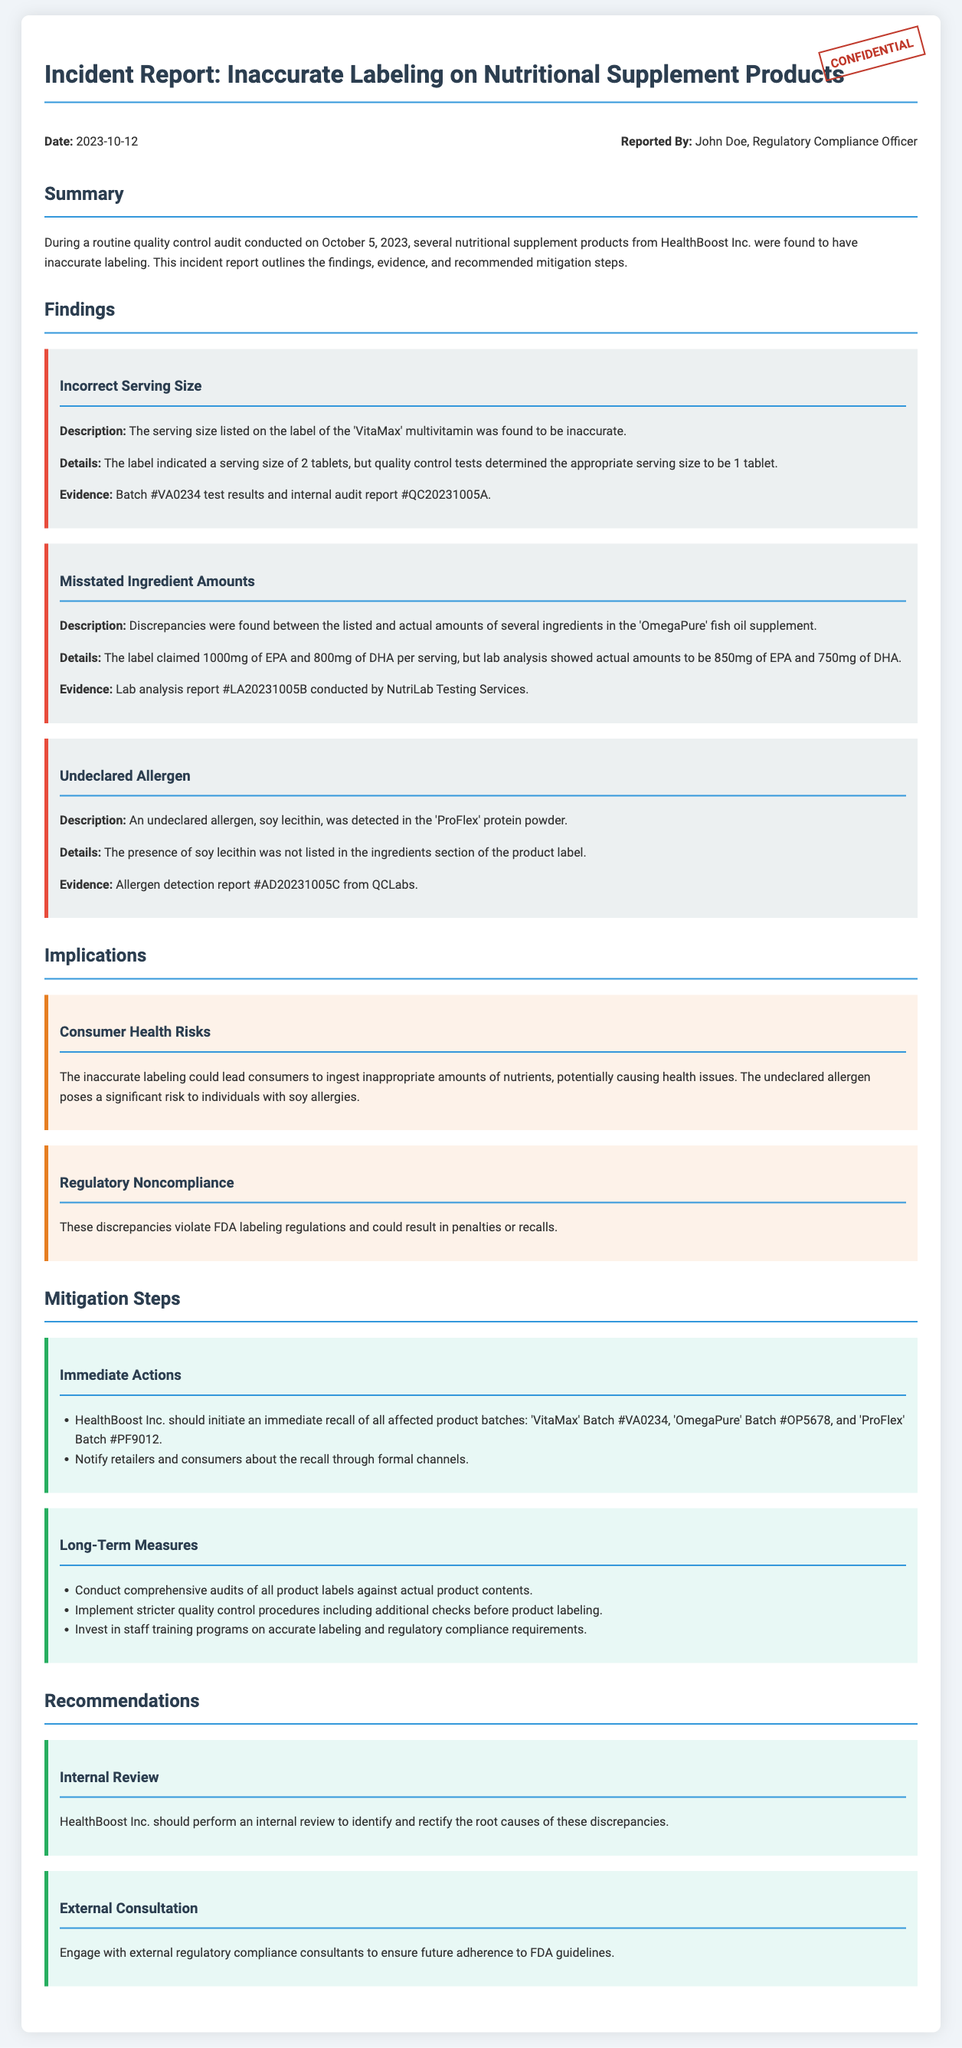what is the date of the incident? The date of the incident is specified in the report as October 5, 2023.
Answer: October 5, 2023 who reported the incident? The person who reported the incident is identified as John Doe.
Answer: John Doe what is the product associated with the incorrect serving size? The product associated with the incorrect serving size is 'VitaMax'.
Answer: 'VitaMax' how much EPA was claimed on the 'OmegaPure' label? The claimed amount of EPA on the 'OmegaPure' label is 1000mg per serving.
Answer: 1000mg what is one health risk mentioned related to inaccurate labeling? One health risk mentioned is that it could lead to inappropriate amounts of nutrients being ingested.
Answer: Inappropriate amounts of nutrients what immediate action should be taken according to the report? The report states that an immediate recall of all affected product batches should be initiated.
Answer: Initiate an immediate recall what long-term measure involves staff development? The long-term measure involving staff development is implementing training programs on accurate labeling.
Answer: Staff training programs which product had an undeclared allergen? The product that had an undeclared allergen is 'ProFlex'.
Answer: 'ProFlex' what is the evidence for the misstated ingredient amounts? The evidence for the misstated ingredient amounts is lab analysis report #LA20231005B.
Answer: Lab analysis report #LA20231005B 